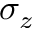<formula> <loc_0><loc_0><loc_500><loc_500>\sigma _ { z }</formula> 